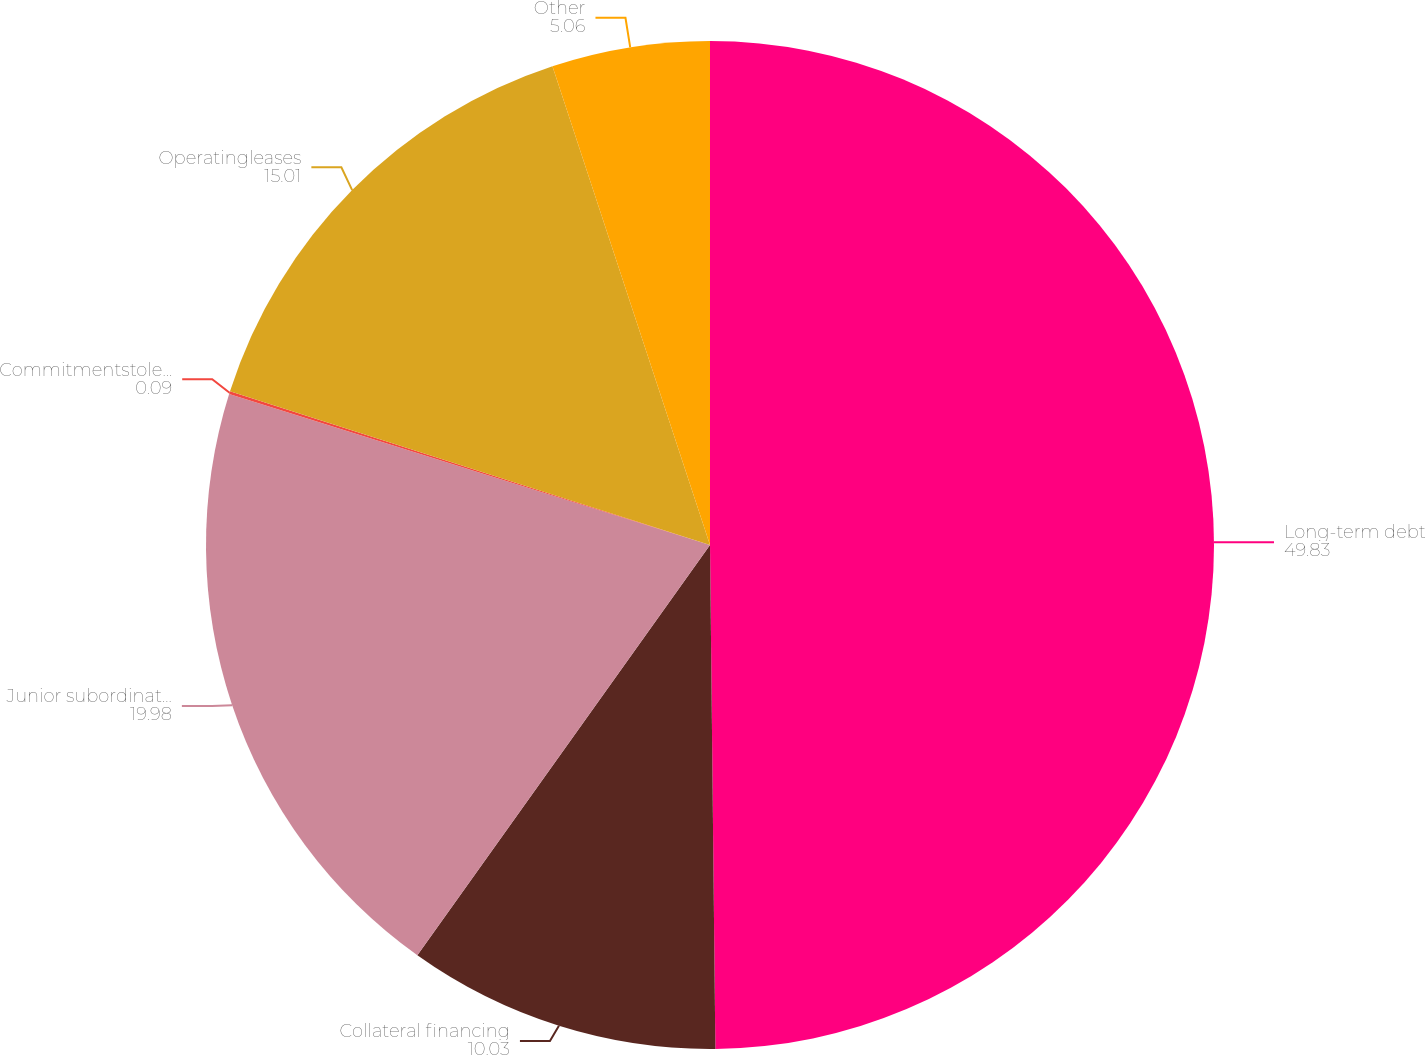Convert chart to OTSL. <chart><loc_0><loc_0><loc_500><loc_500><pie_chart><fcel>Long-term debt<fcel>Collateral financing<fcel>Junior subordinated debt<fcel>Commitmentstolendfunds<fcel>Operatingleases<fcel>Other<nl><fcel>49.83%<fcel>10.03%<fcel>19.98%<fcel>0.09%<fcel>15.01%<fcel>5.06%<nl></chart> 